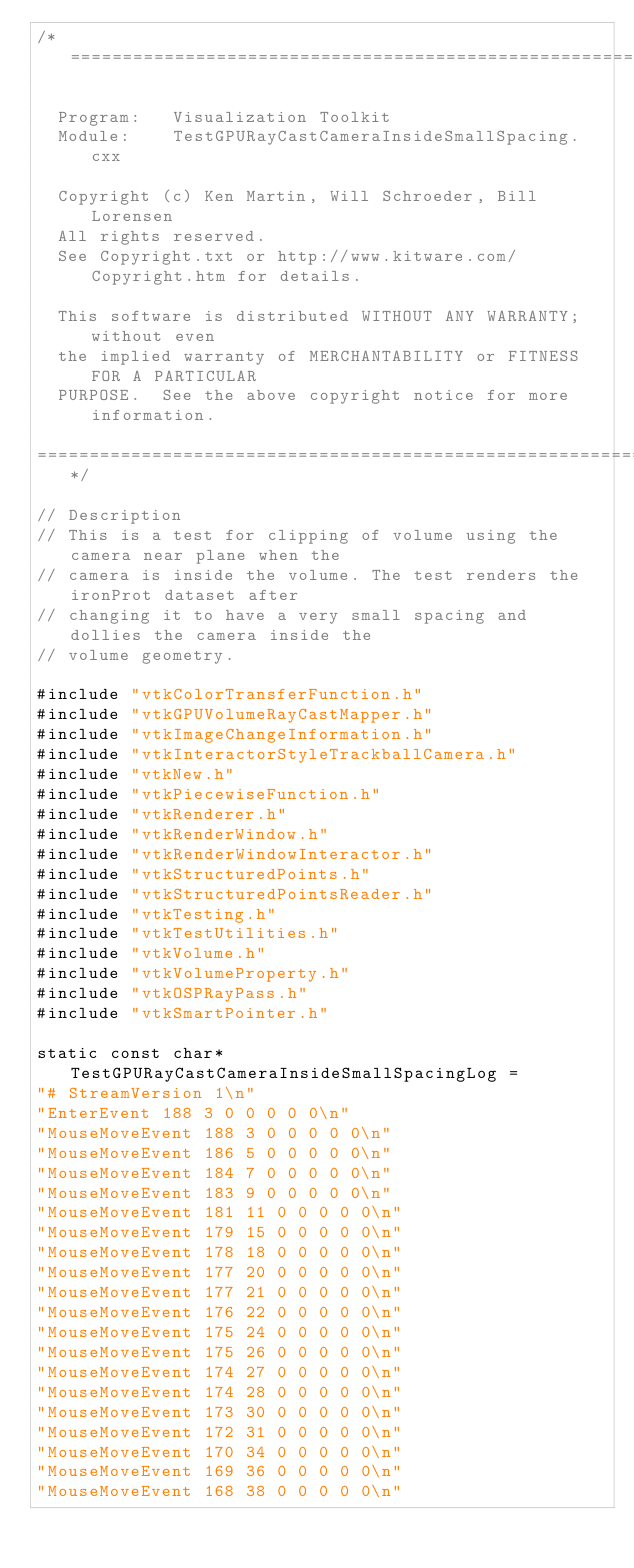<code> <loc_0><loc_0><loc_500><loc_500><_C++_>/*=========================================================================

  Program:   Visualization Toolkit
  Module:    TestGPURayCastCameraInsideSmallSpacing.cxx

  Copyright (c) Ken Martin, Will Schroeder, Bill Lorensen
  All rights reserved.
  See Copyright.txt or http://www.kitware.com/Copyright.htm for details.

  This software is distributed WITHOUT ANY WARRANTY; without even
  the implied warranty of MERCHANTABILITY or FITNESS FOR A PARTICULAR
  PURPOSE.  See the above copyright notice for more information.

=========================================================================*/

// Description
// This is a test for clipping of volume using the camera near plane when the
// camera is inside the volume. The test renders the ironProt dataset after
// changing it to have a very small spacing and dollies the camera inside the
// volume geometry.

#include "vtkColorTransferFunction.h"
#include "vtkGPUVolumeRayCastMapper.h"
#include "vtkImageChangeInformation.h"
#include "vtkInteractorStyleTrackballCamera.h"
#include "vtkNew.h"
#include "vtkPiecewiseFunction.h"
#include "vtkRenderer.h"
#include "vtkRenderWindow.h"
#include "vtkRenderWindowInteractor.h"
#include "vtkStructuredPoints.h"
#include "vtkStructuredPointsReader.h"
#include "vtkTesting.h"
#include "vtkTestUtilities.h"
#include "vtkVolume.h"
#include "vtkVolumeProperty.h"
#include "vtkOSPRayPass.h"
#include "vtkSmartPointer.h"

static const char* TestGPURayCastCameraInsideSmallSpacingLog =
"# StreamVersion 1\n"
"EnterEvent 188 3 0 0 0 0 0\n"
"MouseMoveEvent 188 3 0 0 0 0 0\n"
"MouseMoveEvent 186 5 0 0 0 0 0\n"
"MouseMoveEvent 184 7 0 0 0 0 0\n"
"MouseMoveEvent 183 9 0 0 0 0 0\n"
"MouseMoveEvent 181 11 0 0 0 0 0\n"
"MouseMoveEvent 179 15 0 0 0 0 0\n"
"MouseMoveEvent 178 18 0 0 0 0 0\n"
"MouseMoveEvent 177 20 0 0 0 0 0\n"
"MouseMoveEvent 177 21 0 0 0 0 0\n"
"MouseMoveEvent 176 22 0 0 0 0 0\n"
"MouseMoveEvent 175 24 0 0 0 0 0\n"
"MouseMoveEvent 175 26 0 0 0 0 0\n"
"MouseMoveEvent 174 27 0 0 0 0 0\n"
"MouseMoveEvent 174 28 0 0 0 0 0\n"
"MouseMoveEvent 173 30 0 0 0 0 0\n"
"MouseMoveEvent 172 31 0 0 0 0 0\n"
"MouseMoveEvent 170 34 0 0 0 0 0\n"
"MouseMoveEvent 169 36 0 0 0 0 0\n"
"MouseMoveEvent 168 38 0 0 0 0 0\n"</code> 